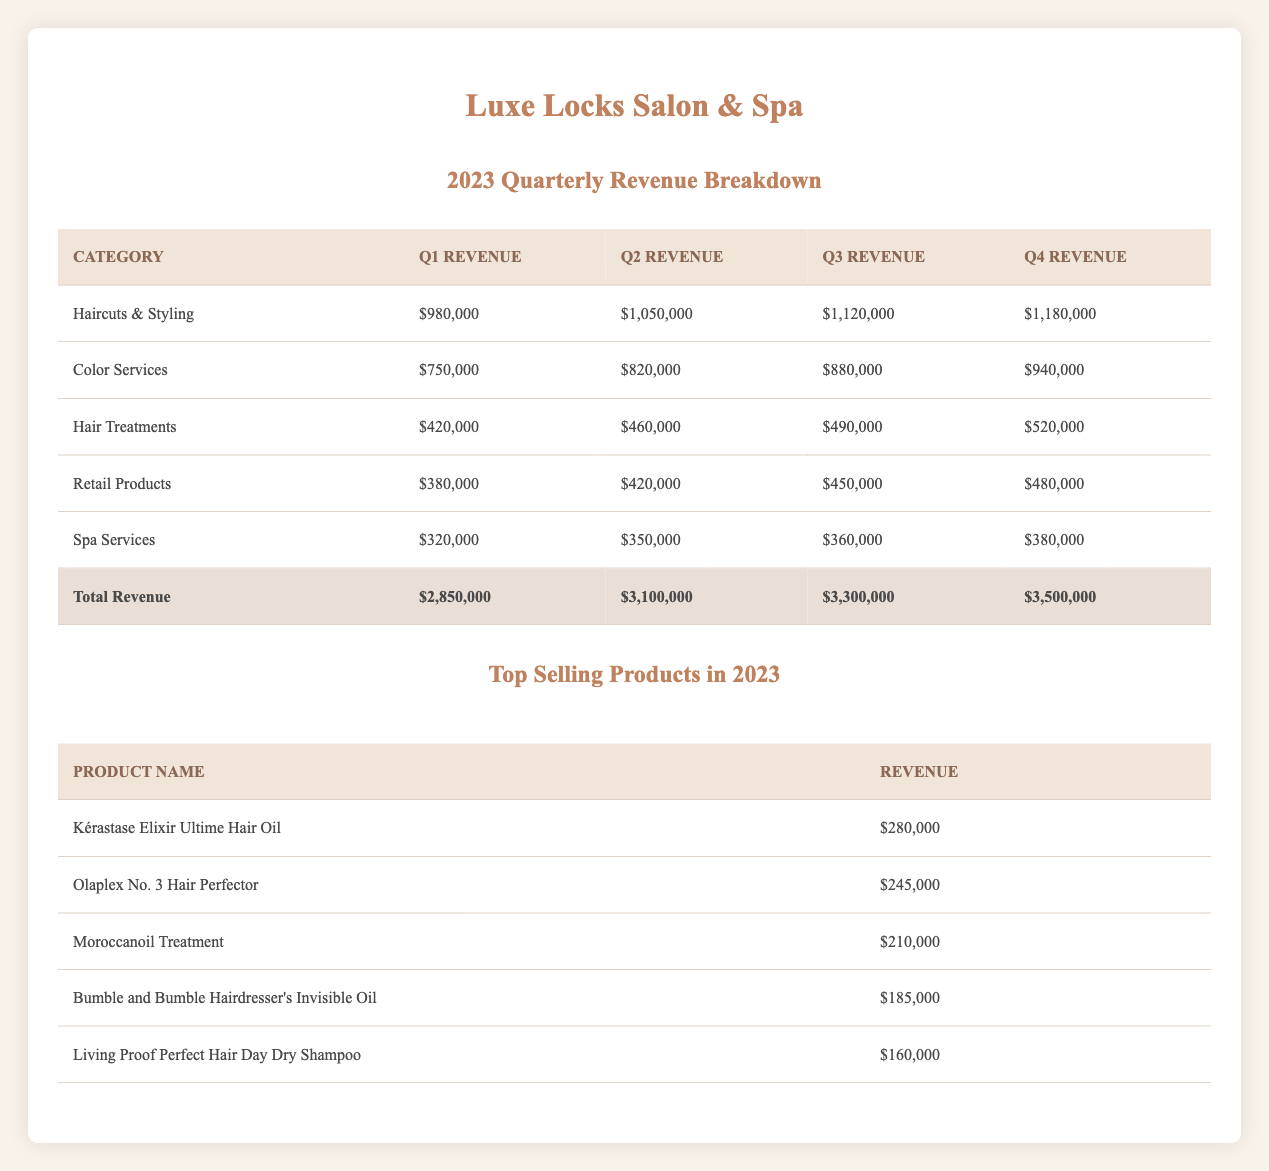What was the total revenue for Q3? The total revenue for Q3 is listed directly in the table under "Total Revenue," where it states it was $3,300,000.
Answer: $3,300,000 Which quarter had the highest revenue from Hair Treatments? Looking at the breakdown for Hair Treatments, the revenue increases each quarter. Q4 has the highest revenue with $520,000.
Answer: Q4 What was the total revenue from Retail Products across all quarters? To find the total revenue from Retail Products, sum the values for all quarters: $380,000 (Q1) + $420,000 (Q2) + $450,000 (Q3) + $480,000 (Q4) = $1,730,000.
Answer: $1,730,000 Did Spa Services generate more revenue in Q2 than in Q1? By comparing the two quarters for Spa Services, we see Q2 revenue was $350,000, while Q1 was $320,000. Therefore, yes, Spa Services generated more in Q2.
Answer: Yes What is the difference in total revenue between Q4 and Q1? The total revenue for Q4 is $3,500,000, and for Q1 it is $2,850,000. The difference is $3,500,000 - $2,850,000 = $650,000.
Answer: $650,000 Which category contributed the most revenue in Q2? In Q2, the breakdown shows "Haircuts & Styling" had the highest revenue of $1,050,000 compared to other categories.
Answer: Haircuts & Styling If we average the total revenue across all quarters, what would that be? To find the average, we first sum the total revenues: $2,850,000 (Q1) + $3,100,000 (Q2) + $3,300,000 (Q3) + $3,500,000 (Q4) = $12,750,000. Then divide by 4 (quarters) to get the average: $12,750,000 / 4 = $3,187,500.
Answer: $3,187,500 What percentage of the total Q1 revenue came from Color Services? In Q1, Color Services generated $750,000 out of the total revenue of $2,850,000. The percentage is ($750,000 / $2,850,000) * 100 = 26.32%.
Answer: 26.32% Was the revenue from the top-selling product "Kérastase Elixir Ultime Hair Oil" greater than the total revenue from "Spa Services" for all quarters combined? First, let's sum the Spa Services revenue: $320,000 (Q1) + $350,000 (Q2) + $360,000 (Q3) + $380,000 (Q4) = $1,410,000. The revenue for "Kérastase Elixir Ultime Hair Oil" is $280,000. Since $280,000 is less than $1,410,000, the answer is no.
Answer: No 